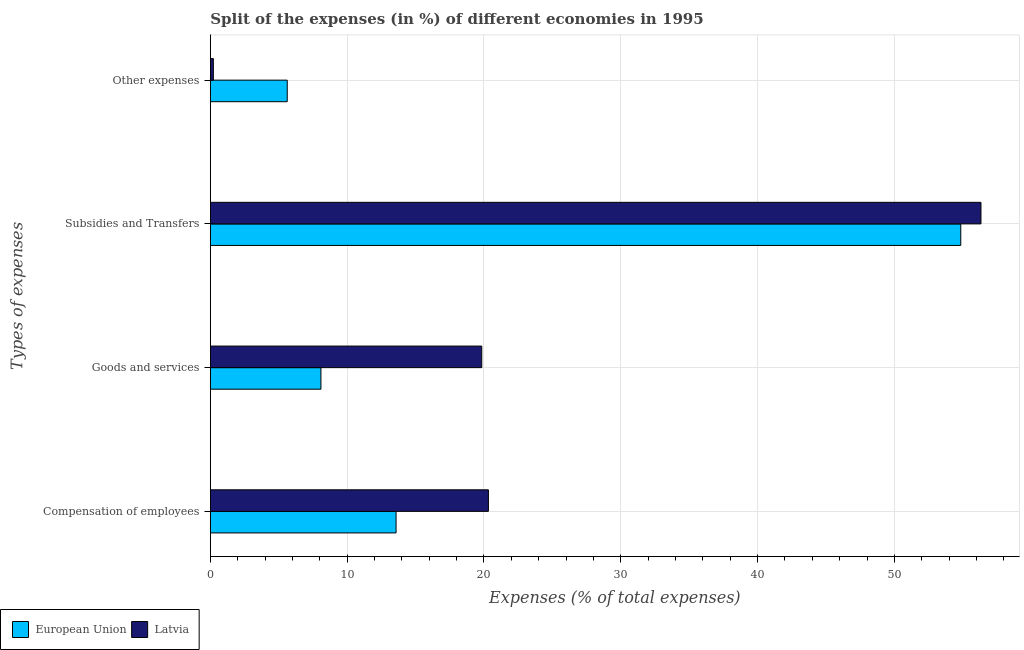Are the number of bars on each tick of the Y-axis equal?
Keep it short and to the point. Yes. How many bars are there on the 1st tick from the top?
Keep it short and to the point. 2. What is the label of the 4th group of bars from the top?
Keep it short and to the point. Compensation of employees. What is the percentage of amount spent on subsidies in European Union?
Make the answer very short. 54.85. Across all countries, what is the maximum percentage of amount spent on goods and services?
Your answer should be compact. 19.84. Across all countries, what is the minimum percentage of amount spent on compensation of employees?
Your answer should be compact. 13.57. In which country was the percentage of amount spent on other expenses minimum?
Ensure brevity in your answer.  Latvia. What is the total percentage of amount spent on other expenses in the graph?
Make the answer very short. 5.83. What is the difference between the percentage of amount spent on compensation of employees in Latvia and that in European Union?
Give a very brief answer. 6.75. What is the difference between the percentage of amount spent on goods and services in Latvia and the percentage of amount spent on other expenses in European Union?
Give a very brief answer. 14.22. What is the average percentage of amount spent on other expenses per country?
Offer a very short reply. 2.92. What is the difference between the percentage of amount spent on compensation of employees and percentage of amount spent on goods and services in European Union?
Provide a succinct answer. 5.49. What is the ratio of the percentage of amount spent on compensation of employees in Latvia to that in European Union?
Provide a short and direct response. 1.5. Is the difference between the percentage of amount spent on other expenses in Latvia and European Union greater than the difference between the percentage of amount spent on goods and services in Latvia and European Union?
Give a very brief answer. No. What is the difference between the highest and the second highest percentage of amount spent on goods and services?
Provide a short and direct response. 11.75. What is the difference between the highest and the lowest percentage of amount spent on compensation of employees?
Your answer should be very brief. 6.75. In how many countries, is the percentage of amount spent on compensation of employees greater than the average percentage of amount spent on compensation of employees taken over all countries?
Ensure brevity in your answer.  1. Is it the case that in every country, the sum of the percentage of amount spent on other expenses and percentage of amount spent on subsidies is greater than the sum of percentage of amount spent on goods and services and percentage of amount spent on compensation of employees?
Keep it short and to the point. Yes. What does the 2nd bar from the bottom in Goods and services represents?
Your answer should be compact. Latvia. Is it the case that in every country, the sum of the percentage of amount spent on compensation of employees and percentage of amount spent on goods and services is greater than the percentage of amount spent on subsidies?
Ensure brevity in your answer.  No. How many bars are there?
Provide a short and direct response. 8. Are all the bars in the graph horizontal?
Your answer should be very brief. Yes. Does the graph contain any zero values?
Provide a short and direct response. No. Where does the legend appear in the graph?
Offer a very short reply. Bottom left. How many legend labels are there?
Your answer should be compact. 2. How are the legend labels stacked?
Your answer should be very brief. Horizontal. What is the title of the graph?
Offer a terse response. Split of the expenses (in %) of different economies in 1995. What is the label or title of the X-axis?
Provide a succinct answer. Expenses (% of total expenses). What is the label or title of the Y-axis?
Ensure brevity in your answer.  Types of expenses. What is the Expenses (% of total expenses) in European Union in Compensation of employees?
Provide a succinct answer. 13.57. What is the Expenses (% of total expenses) in Latvia in Compensation of employees?
Ensure brevity in your answer.  20.32. What is the Expenses (% of total expenses) of European Union in Goods and services?
Offer a very short reply. 8.08. What is the Expenses (% of total expenses) in Latvia in Goods and services?
Provide a short and direct response. 19.84. What is the Expenses (% of total expenses) of European Union in Subsidies and Transfers?
Your answer should be compact. 54.85. What is the Expenses (% of total expenses) of Latvia in Subsidies and Transfers?
Keep it short and to the point. 56.33. What is the Expenses (% of total expenses) in European Union in Other expenses?
Your answer should be compact. 5.62. What is the Expenses (% of total expenses) in Latvia in Other expenses?
Make the answer very short. 0.22. Across all Types of expenses, what is the maximum Expenses (% of total expenses) of European Union?
Your response must be concise. 54.85. Across all Types of expenses, what is the maximum Expenses (% of total expenses) of Latvia?
Your answer should be compact. 56.33. Across all Types of expenses, what is the minimum Expenses (% of total expenses) in European Union?
Keep it short and to the point. 5.62. Across all Types of expenses, what is the minimum Expenses (% of total expenses) in Latvia?
Your answer should be very brief. 0.22. What is the total Expenses (% of total expenses) of European Union in the graph?
Provide a succinct answer. 82.12. What is the total Expenses (% of total expenses) in Latvia in the graph?
Provide a short and direct response. 96.7. What is the difference between the Expenses (% of total expenses) in European Union in Compensation of employees and that in Goods and services?
Your answer should be compact. 5.49. What is the difference between the Expenses (% of total expenses) of Latvia in Compensation of employees and that in Goods and services?
Offer a very short reply. 0.49. What is the difference between the Expenses (% of total expenses) in European Union in Compensation of employees and that in Subsidies and Transfers?
Give a very brief answer. -41.28. What is the difference between the Expenses (% of total expenses) in Latvia in Compensation of employees and that in Subsidies and Transfers?
Your answer should be very brief. -36.01. What is the difference between the Expenses (% of total expenses) of European Union in Compensation of employees and that in Other expenses?
Your answer should be very brief. 7.96. What is the difference between the Expenses (% of total expenses) of Latvia in Compensation of employees and that in Other expenses?
Offer a terse response. 20.11. What is the difference between the Expenses (% of total expenses) of European Union in Goods and services and that in Subsidies and Transfers?
Offer a terse response. -46.77. What is the difference between the Expenses (% of total expenses) in Latvia in Goods and services and that in Subsidies and Transfers?
Give a very brief answer. -36.49. What is the difference between the Expenses (% of total expenses) in European Union in Goods and services and that in Other expenses?
Provide a short and direct response. 2.46. What is the difference between the Expenses (% of total expenses) in Latvia in Goods and services and that in Other expenses?
Offer a very short reply. 19.62. What is the difference between the Expenses (% of total expenses) of European Union in Subsidies and Transfers and that in Other expenses?
Make the answer very short. 49.23. What is the difference between the Expenses (% of total expenses) of Latvia in Subsidies and Transfers and that in Other expenses?
Ensure brevity in your answer.  56.11. What is the difference between the Expenses (% of total expenses) in European Union in Compensation of employees and the Expenses (% of total expenses) in Latvia in Goods and services?
Offer a terse response. -6.26. What is the difference between the Expenses (% of total expenses) of European Union in Compensation of employees and the Expenses (% of total expenses) of Latvia in Subsidies and Transfers?
Offer a terse response. -42.76. What is the difference between the Expenses (% of total expenses) in European Union in Compensation of employees and the Expenses (% of total expenses) in Latvia in Other expenses?
Ensure brevity in your answer.  13.35. What is the difference between the Expenses (% of total expenses) of European Union in Goods and services and the Expenses (% of total expenses) of Latvia in Subsidies and Transfers?
Offer a terse response. -48.25. What is the difference between the Expenses (% of total expenses) in European Union in Goods and services and the Expenses (% of total expenses) in Latvia in Other expenses?
Provide a short and direct response. 7.86. What is the difference between the Expenses (% of total expenses) of European Union in Subsidies and Transfers and the Expenses (% of total expenses) of Latvia in Other expenses?
Your answer should be compact. 54.63. What is the average Expenses (% of total expenses) in European Union per Types of expenses?
Your response must be concise. 20.53. What is the average Expenses (% of total expenses) in Latvia per Types of expenses?
Your response must be concise. 24.18. What is the difference between the Expenses (% of total expenses) of European Union and Expenses (% of total expenses) of Latvia in Compensation of employees?
Keep it short and to the point. -6.75. What is the difference between the Expenses (% of total expenses) in European Union and Expenses (% of total expenses) in Latvia in Goods and services?
Make the answer very short. -11.75. What is the difference between the Expenses (% of total expenses) of European Union and Expenses (% of total expenses) of Latvia in Subsidies and Transfers?
Keep it short and to the point. -1.48. What is the difference between the Expenses (% of total expenses) of European Union and Expenses (% of total expenses) of Latvia in Other expenses?
Your answer should be very brief. 5.4. What is the ratio of the Expenses (% of total expenses) of European Union in Compensation of employees to that in Goods and services?
Your response must be concise. 1.68. What is the ratio of the Expenses (% of total expenses) of Latvia in Compensation of employees to that in Goods and services?
Provide a short and direct response. 1.02. What is the ratio of the Expenses (% of total expenses) in European Union in Compensation of employees to that in Subsidies and Transfers?
Offer a terse response. 0.25. What is the ratio of the Expenses (% of total expenses) in Latvia in Compensation of employees to that in Subsidies and Transfers?
Your answer should be compact. 0.36. What is the ratio of the Expenses (% of total expenses) of European Union in Compensation of employees to that in Other expenses?
Make the answer very short. 2.42. What is the ratio of the Expenses (% of total expenses) in Latvia in Compensation of employees to that in Other expenses?
Your answer should be compact. 93.4. What is the ratio of the Expenses (% of total expenses) of European Union in Goods and services to that in Subsidies and Transfers?
Provide a short and direct response. 0.15. What is the ratio of the Expenses (% of total expenses) in Latvia in Goods and services to that in Subsidies and Transfers?
Offer a very short reply. 0.35. What is the ratio of the Expenses (% of total expenses) of European Union in Goods and services to that in Other expenses?
Your answer should be very brief. 1.44. What is the ratio of the Expenses (% of total expenses) of Latvia in Goods and services to that in Other expenses?
Keep it short and to the point. 91.16. What is the ratio of the Expenses (% of total expenses) of European Union in Subsidies and Transfers to that in Other expenses?
Ensure brevity in your answer.  9.76. What is the ratio of the Expenses (% of total expenses) of Latvia in Subsidies and Transfers to that in Other expenses?
Your answer should be very brief. 258.86. What is the difference between the highest and the second highest Expenses (% of total expenses) in European Union?
Make the answer very short. 41.28. What is the difference between the highest and the second highest Expenses (% of total expenses) of Latvia?
Your answer should be very brief. 36.01. What is the difference between the highest and the lowest Expenses (% of total expenses) in European Union?
Keep it short and to the point. 49.23. What is the difference between the highest and the lowest Expenses (% of total expenses) of Latvia?
Your answer should be compact. 56.11. 